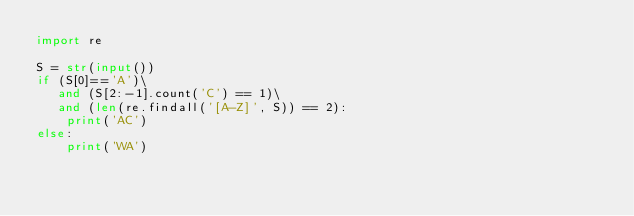Convert code to text. <code><loc_0><loc_0><loc_500><loc_500><_Python_>import re

S = str(input())
if (S[0]=='A')\
   and (S[2:-1].count('C') == 1)\
   and (len(re.findall('[A-Z]', S)) == 2):
    print('AC')
else:
    print('WA')</code> 